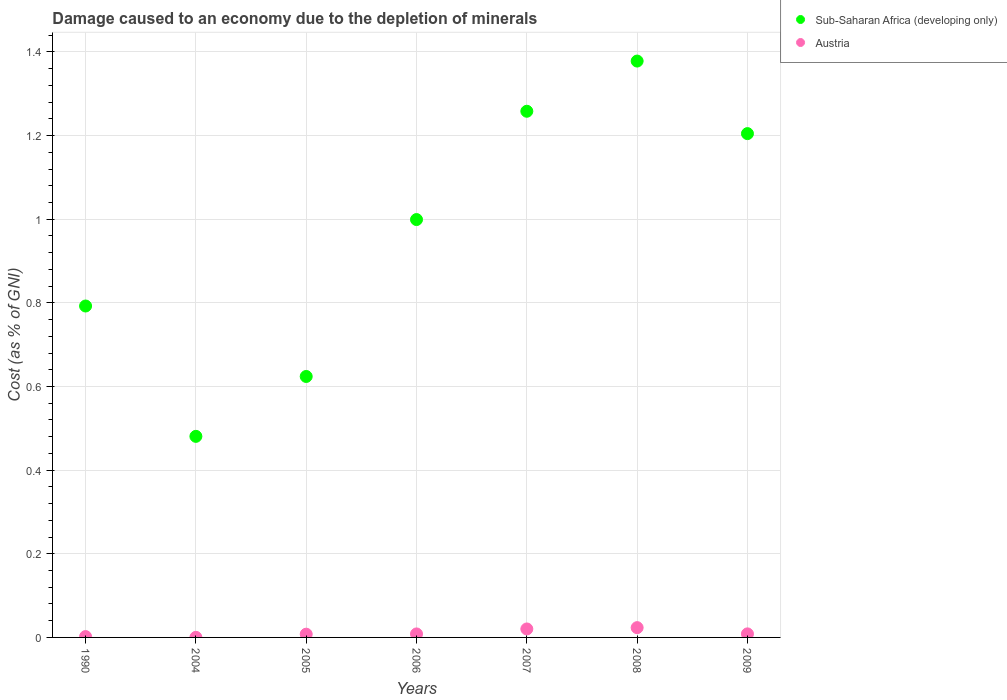How many different coloured dotlines are there?
Provide a short and direct response. 2. Is the number of dotlines equal to the number of legend labels?
Ensure brevity in your answer.  Yes. What is the cost of damage caused due to the depletion of minerals in Sub-Saharan Africa (developing only) in 2009?
Provide a succinct answer. 1.2. Across all years, what is the maximum cost of damage caused due to the depletion of minerals in Sub-Saharan Africa (developing only)?
Provide a succinct answer. 1.38. Across all years, what is the minimum cost of damage caused due to the depletion of minerals in Sub-Saharan Africa (developing only)?
Your answer should be very brief. 0.48. In which year was the cost of damage caused due to the depletion of minerals in Sub-Saharan Africa (developing only) maximum?
Provide a succinct answer. 2008. In which year was the cost of damage caused due to the depletion of minerals in Sub-Saharan Africa (developing only) minimum?
Ensure brevity in your answer.  2004. What is the total cost of damage caused due to the depletion of minerals in Sub-Saharan Africa (developing only) in the graph?
Provide a short and direct response. 6.74. What is the difference between the cost of damage caused due to the depletion of minerals in Austria in 2004 and that in 2005?
Keep it short and to the point. -0.01. What is the difference between the cost of damage caused due to the depletion of minerals in Sub-Saharan Africa (developing only) in 2005 and the cost of damage caused due to the depletion of minerals in Austria in 1990?
Keep it short and to the point. 0.62. What is the average cost of damage caused due to the depletion of minerals in Sub-Saharan Africa (developing only) per year?
Provide a succinct answer. 0.96. In the year 2006, what is the difference between the cost of damage caused due to the depletion of minerals in Austria and cost of damage caused due to the depletion of minerals in Sub-Saharan Africa (developing only)?
Provide a short and direct response. -0.99. What is the ratio of the cost of damage caused due to the depletion of minerals in Austria in 1990 to that in 2004?
Make the answer very short. 10.62. Is the cost of damage caused due to the depletion of minerals in Sub-Saharan Africa (developing only) in 2004 less than that in 2009?
Make the answer very short. Yes. What is the difference between the highest and the second highest cost of damage caused due to the depletion of minerals in Austria?
Ensure brevity in your answer.  0. What is the difference between the highest and the lowest cost of damage caused due to the depletion of minerals in Austria?
Offer a terse response. 0.02. Is the sum of the cost of damage caused due to the depletion of minerals in Sub-Saharan Africa (developing only) in 2004 and 2008 greater than the maximum cost of damage caused due to the depletion of minerals in Austria across all years?
Your answer should be compact. Yes. Does the cost of damage caused due to the depletion of minerals in Austria monotonically increase over the years?
Keep it short and to the point. No. Is the cost of damage caused due to the depletion of minerals in Sub-Saharan Africa (developing only) strictly greater than the cost of damage caused due to the depletion of minerals in Austria over the years?
Your response must be concise. Yes. Is the cost of damage caused due to the depletion of minerals in Sub-Saharan Africa (developing only) strictly less than the cost of damage caused due to the depletion of minerals in Austria over the years?
Make the answer very short. No. How many years are there in the graph?
Make the answer very short. 7. What is the difference between two consecutive major ticks on the Y-axis?
Provide a short and direct response. 0.2. Are the values on the major ticks of Y-axis written in scientific E-notation?
Give a very brief answer. No. Does the graph contain grids?
Keep it short and to the point. Yes. How many legend labels are there?
Offer a terse response. 2. How are the legend labels stacked?
Offer a very short reply. Vertical. What is the title of the graph?
Make the answer very short. Damage caused to an economy due to the depletion of minerals. Does "Myanmar" appear as one of the legend labels in the graph?
Ensure brevity in your answer.  No. What is the label or title of the Y-axis?
Keep it short and to the point. Cost (as % of GNI). What is the Cost (as % of GNI) in Sub-Saharan Africa (developing only) in 1990?
Keep it short and to the point. 0.79. What is the Cost (as % of GNI) in Austria in 1990?
Offer a very short reply. 0. What is the Cost (as % of GNI) in Sub-Saharan Africa (developing only) in 2004?
Your response must be concise. 0.48. What is the Cost (as % of GNI) of Austria in 2004?
Provide a succinct answer. 0. What is the Cost (as % of GNI) in Sub-Saharan Africa (developing only) in 2005?
Ensure brevity in your answer.  0.62. What is the Cost (as % of GNI) of Austria in 2005?
Keep it short and to the point. 0.01. What is the Cost (as % of GNI) of Sub-Saharan Africa (developing only) in 2006?
Give a very brief answer. 1. What is the Cost (as % of GNI) of Austria in 2006?
Offer a terse response. 0.01. What is the Cost (as % of GNI) of Sub-Saharan Africa (developing only) in 2007?
Offer a terse response. 1.26. What is the Cost (as % of GNI) in Austria in 2007?
Make the answer very short. 0.02. What is the Cost (as % of GNI) of Sub-Saharan Africa (developing only) in 2008?
Offer a very short reply. 1.38. What is the Cost (as % of GNI) in Austria in 2008?
Make the answer very short. 0.02. What is the Cost (as % of GNI) in Sub-Saharan Africa (developing only) in 2009?
Keep it short and to the point. 1.2. What is the Cost (as % of GNI) in Austria in 2009?
Offer a very short reply. 0.01. Across all years, what is the maximum Cost (as % of GNI) of Sub-Saharan Africa (developing only)?
Provide a short and direct response. 1.38. Across all years, what is the maximum Cost (as % of GNI) in Austria?
Make the answer very short. 0.02. Across all years, what is the minimum Cost (as % of GNI) of Sub-Saharan Africa (developing only)?
Make the answer very short. 0.48. Across all years, what is the minimum Cost (as % of GNI) of Austria?
Make the answer very short. 0. What is the total Cost (as % of GNI) in Sub-Saharan Africa (developing only) in the graph?
Keep it short and to the point. 6.74. What is the total Cost (as % of GNI) in Austria in the graph?
Offer a terse response. 0.07. What is the difference between the Cost (as % of GNI) of Sub-Saharan Africa (developing only) in 1990 and that in 2004?
Give a very brief answer. 0.31. What is the difference between the Cost (as % of GNI) of Austria in 1990 and that in 2004?
Your answer should be compact. 0. What is the difference between the Cost (as % of GNI) of Sub-Saharan Africa (developing only) in 1990 and that in 2005?
Your response must be concise. 0.17. What is the difference between the Cost (as % of GNI) of Austria in 1990 and that in 2005?
Offer a terse response. -0.01. What is the difference between the Cost (as % of GNI) of Sub-Saharan Africa (developing only) in 1990 and that in 2006?
Make the answer very short. -0.21. What is the difference between the Cost (as % of GNI) in Austria in 1990 and that in 2006?
Ensure brevity in your answer.  -0.01. What is the difference between the Cost (as % of GNI) of Sub-Saharan Africa (developing only) in 1990 and that in 2007?
Your answer should be compact. -0.47. What is the difference between the Cost (as % of GNI) in Austria in 1990 and that in 2007?
Offer a terse response. -0.02. What is the difference between the Cost (as % of GNI) of Sub-Saharan Africa (developing only) in 1990 and that in 2008?
Keep it short and to the point. -0.59. What is the difference between the Cost (as % of GNI) in Austria in 1990 and that in 2008?
Keep it short and to the point. -0.02. What is the difference between the Cost (as % of GNI) of Sub-Saharan Africa (developing only) in 1990 and that in 2009?
Ensure brevity in your answer.  -0.41. What is the difference between the Cost (as % of GNI) of Austria in 1990 and that in 2009?
Make the answer very short. -0.01. What is the difference between the Cost (as % of GNI) of Sub-Saharan Africa (developing only) in 2004 and that in 2005?
Make the answer very short. -0.14. What is the difference between the Cost (as % of GNI) in Austria in 2004 and that in 2005?
Offer a terse response. -0.01. What is the difference between the Cost (as % of GNI) in Sub-Saharan Africa (developing only) in 2004 and that in 2006?
Offer a terse response. -0.52. What is the difference between the Cost (as % of GNI) of Austria in 2004 and that in 2006?
Offer a terse response. -0.01. What is the difference between the Cost (as % of GNI) in Sub-Saharan Africa (developing only) in 2004 and that in 2007?
Offer a terse response. -0.78. What is the difference between the Cost (as % of GNI) in Austria in 2004 and that in 2007?
Ensure brevity in your answer.  -0.02. What is the difference between the Cost (as % of GNI) in Sub-Saharan Africa (developing only) in 2004 and that in 2008?
Your answer should be compact. -0.9. What is the difference between the Cost (as % of GNI) of Austria in 2004 and that in 2008?
Give a very brief answer. -0.02. What is the difference between the Cost (as % of GNI) in Sub-Saharan Africa (developing only) in 2004 and that in 2009?
Provide a short and direct response. -0.72. What is the difference between the Cost (as % of GNI) in Austria in 2004 and that in 2009?
Make the answer very short. -0.01. What is the difference between the Cost (as % of GNI) of Sub-Saharan Africa (developing only) in 2005 and that in 2006?
Provide a short and direct response. -0.38. What is the difference between the Cost (as % of GNI) in Austria in 2005 and that in 2006?
Give a very brief answer. -0. What is the difference between the Cost (as % of GNI) in Sub-Saharan Africa (developing only) in 2005 and that in 2007?
Your response must be concise. -0.63. What is the difference between the Cost (as % of GNI) of Austria in 2005 and that in 2007?
Offer a very short reply. -0.01. What is the difference between the Cost (as % of GNI) in Sub-Saharan Africa (developing only) in 2005 and that in 2008?
Give a very brief answer. -0.75. What is the difference between the Cost (as % of GNI) in Austria in 2005 and that in 2008?
Offer a terse response. -0.02. What is the difference between the Cost (as % of GNI) in Sub-Saharan Africa (developing only) in 2005 and that in 2009?
Ensure brevity in your answer.  -0.58. What is the difference between the Cost (as % of GNI) of Austria in 2005 and that in 2009?
Make the answer very short. -0. What is the difference between the Cost (as % of GNI) of Sub-Saharan Africa (developing only) in 2006 and that in 2007?
Provide a succinct answer. -0.26. What is the difference between the Cost (as % of GNI) in Austria in 2006 and that in 2007?
Offer a terse response. -0.01. What is the difference between the Cost (as % of GNI) of Sub-Saharan Africa (developing only) in 2006 and that in 2008?
Give a very brief answer. -0.38. What is the difference between the Cost (as % of GNI) in Austria in 2006 and that in 2008?
Your answer should be compact. -0.01. What is the difference between the Cost (as % of GNI) in Sub-Saharan Africa (developing only) in 2006 and that in 2009?
Ensure brevity in your answer.  -0.21. What is the difference between the Cost (as % of GNI) of Austria in 2006 and that in 2009?
Make the answer very short. -0. What is the difference between the Cost (as % of GNI) in Sub-Saharan Africa (developing only) in 2007 and that in 2008?
Your response must be concise. -0.12. What is the difference between the Cost (as % of GNI) in Austria in 2007 and that in 2008?
Ensure brevity in your answer.  -0. What is the difference between the Cost (as % of GNI) of Sub-Saharan Africa (developing only) in 2007 and that in 2009?
Provide a short and direct response. 0.05. What is the difference between the Cost (as % of GNI) in Austria in 2007 and that in 2009?
Make the answer very short. 0.01. What is the difference between the Cost (as % of GNI) in Sub-Saharan Africa (developing only) in 2008 and that in 2009?
Your answer should be compact. 0.17. What is the difference between the Cost (as % of GNI) in Austria in 2008 and that in 2009?
Your response must be concise. 0.01. What is the difference between the Cost (as % of GNI) in Sub-Saharan Africa (developing only) in 1990 and the Cost (as % of GNI) in Austria in 2004?
Offer a terse response. 0.79. What is the difference between the Cost (as % of GNI) in Sub-Saharan Africa (developing only) in 1990 and the Cost (as % of GNI) in Austria in 2005?
Keep it short and to the point. 0.78. What is the difference between the Cost (as % of GNI) of Sub-Saharan Africa (developing only) in 1990 and the Cost (as % of GNI) of Austria in 2006?
Offer a terse response. 0.78. What is the difference between the Cost (as % of GNI) in Sub-Saharan Africa (developing only) in 1990 and the Cost (as % of GNI) in Austria in 2007?
Provide a short and direct response. 0.77. What is the difference between the Cost (as % of GNI) in Sub-Saharan Africa (developing only) in 1990 and the Cost (as % of GNI) in Austria in 2008?
Provide a short and direct response. 0.77. What is the difference between the Cost (as % of GNI) in Sub-Saharan Africa (developing only) in 1990 and the Cost (as % of GNI) in Austria in 2009?
Offer a very short reply. 0.78. What is the difference between the Cost (as % of GNI) of Sub-Saharan Africa (developing only) in 2004 and the Cost (as % of GNI) of Austria in 2005?
Provide a succinct answer. 0.47. What is the difference between the Cost (as % of GNI) in Sub-Saharan Africa (developing only) in 2004 and the Cost (as % of GNI) in Austria in 2006?
Offer a terse response. 0.47. What is the difference between the Cost (as % of GNI) in Sub-Saharan Africa (developing only) in 2004 and the Cost (as % of GNI) in Austria in 2007?
Your response must be concise. 0.46. What is the difference between the Cost (as % of GNI) of Sub-Saharan Africa (developing only) in 2004 and the Cost (as % of GNI) of Austria in 2008?
Make the answer very short. 0.46. What is the difference between the Cost (as % of GNI) of Sub-Saharan Africa (developing only) in 2004 and the Cost (as % of GNI) of Austria in 2009?
Your answer should be very brief. 0.47. What is the difference between the Cost (as % of GNI) of Sub-Saharan Africa (developing only) in 2005 and the Cost (as % of GNI) of Austria in 2006?
Offer a very short reply. 0.62. What is the difference between the Cost (as % of GNI) in Sub-Saharan Africa (developing only) in 2005 and the Cost (as % of GNI) in Austria in 2007?
Offer a very short reply. 0.6. What is the difference between the Cost (as % of GNI) in Sub-Saharan Africa (developing only) in 2005 and the Cost (as % of GNI) in Austria in 2008?
Offer a very short reply. 0.6. What is the difference between the Cost (as % of GNI) in Sub-Saharan Africa (developing only) in 2005 and the Cost (as % of GNI) in Austria in 2009?
Offer a terse response. 0.62. What is the difference between the Cost (as % of GNI) of Sub-Saharan Africa (developing only) in 2006 and the Cost (as % of GNI) of Austria in 2008?
Your response must be concise. 0.98. What is the difference between the Cost (as % of GNI) in Sub-Saharan Africa (developing only) in 2007 and the Cost (as % of GNI) in Austria in 2008?
Your answer should be very brief. 1.23. What is the difference between the Cost (as % of GNI) of Sub-Saharan Africa (developing only) in 2007 and the Cost (as % of GNI) of Austria in 2009?
Offer a terse response. 1.25. What is the difference between the Cost (as % of GNI) of Sub-Saharan Africa (developing only) in 2008 and the Cost (as % of GNI) of Austria in 2009?
Your answer should be compact. 1.37. What is the average Cost (as % of GNI) of Sub-Saharan Africa (developing only) per year?
Keep it short and to the point. 0.96. What is the average Cost (as % of GNI) of Austria per year?
Your answer should be compact. 0.01. In the year 1990, what is the difference between the Cost (as % of GNI) in Sub-Saharan Africa (developing only) and Cost (as % of GNI) in Austria?
Ensure brevity in your answer.  0.79. In the year 2004, what is the difference between the Cost (as % of GNI) of Sub-Saharan Africa (developing only) and Cost (as % of GNI) of Austria?
Your answer should be very brief. 0.48. In the year 2005, what is the difference between the Cost (as % of GNI) in Sub-Saharan Africa (developing only) and Cost (as % of GNI) in Austria?
Provide a succinct answer. 0.62. In the year 2006, what is the difference between the Cost (as % of GNI) of Sub-Saharan Africa (developing only) and Cost (as % of GNI) of Austria?
Provide a short and direct response. 0.99. In the year 2007, what is the difference between the Cost (as % of GNI) of Sub-Saharan Africa (developing only) and Cost (as % of GNI) of Austria?
Your answer should be very brief. 1.24. In the year 2008, what is the difference between the Cost (as % of GNI) of Sub-Saharan Africa (developing only) and Cost (as % of GNI) of Austria?
Your answer should be compact. 1.35. In the year 2009, what is the difference between the Cost (as % of GNI) of Sub-Saharan Africa (developing only) and Cost (as % of GNI) of Austria?
Keep it short and to the point. 1.2. What is the ratio of the Cost (as % of GNI) of Sub-Saharan Africa (developing only) in 1990 to that in 2004?
Provide a succinct answer. 1.65. What is the ratio of the Cost (as % of GNI) of Austria in 1990 to that in 2004?
Your answer should be very brief. 10.62. What is the ratio of the Cost (as % of GNI) of Sub-Saharan Africa (developing only) in 1990 to that in 2005?
Give a very brief answer. 1.27. What is the ratio of the Cost (as % of GNI) of Austria in 1990 to that in 2005?
Make the answer very short. 0.26. What is the ratio of the Cost (as % of GNI) of Sub-Saharan Africa (developing only) in 1990 to that in 2006?
Your response must be concise. 0.79. What is the ratio of the Cost (as % of GNI) in Austria in 1990 to that in 2006?
Provide a succinct answer. 0.24. What is the ratio of the Cost (as % of GNI) of Sub-Saharan Africa (developing only) in 1990 to that in 2007?
Your response must be concise. 0.63. What is the ratio of the Cost (as % of GNI) in Austria in 1990 to that in 2007?
Your answer should be compact. 0.1. What is the ratio of the Cost (as % of GNI) of Sub-Saharan Africa (developing only) in 1990 to that in 2008?
Offer a very short reply. 0.57. What is the ratio of the Cost (as % of GNI) of Austria in 1990 to that in 2008?
Make the answer very short. 0.09. What is the ratio of the Cost (as % of GNI) in Sub-Saharan Africa (developing only) in 1990 to that in 2009?
Ensure brevity in your answer.  0.66. What is the ratio of the Cost (as % of GNI) of Austria in 1990 to that in 2009?
Your response must be concise. 0.24. What is the ratio of the Cost (as % of GNI) of Sub-Saharan Africa (developing only) in 2004 to that in 2005?
Make the answer very short. 0.77. What is the ratio of the Cost (as % of GNI) in Austria in 2004 to that in 2005?
Keep it short and to the point. 0.02. What is the ratio of the Cost (as % of GNI) in Sub-Saharan Africa (developing only) in 2004 to that in 2006?
Give a very brief answer. 0.48. What is the ratio of the Cost (as % of GNI) in Austria in 2004 to that in 2006?
Give a very brief answer. 0.02. What is the ratio of the Cost (as % of GNI) in Sub-Saharan Africa (developing only) in 2004 to that in 2007?
Keep it short and to the point. 0.38. What is the ratio of the Cost (as % of GNI) of Austria in 2004 to that in 2007?
Provide a short and direct response. 0.01. What is the ratio of the Cost (as % of GNI) of Sub-Saharan Africa (developing only) in 2004 to that in 2008?
Ensure brevity in your answer.  0.35. What is the ratio of the Cost (as % of GNI) in Austria in 2004 to that in 2008?
Offer a very short reply. 0.01. What is the ratio of the Cost (as % of GNI) in Sub-Saharan Africa (developing only) in 2004 to that in 2009?
Offer a very short reply. 0.4. What is the ratio of the Cost (as % of GNI) of Austria in 2004 to that in 2009?
Your response must be concise. 0.02. What is the ratio of the Cost (as % of GNI) in Sub-Saharan Africa (developing only) in 2005 to that in 2006?
Your response must be concise. 0.62. What is the ratio of the Cost (as % of GNI) in Austria in 2005 to that in 2006?
Ensure brevity in your answer.  0.93. What is the ratio of the Cost (as % of GNI) of Sub-Saharan Africa (developing only) in 2005 to that in 2007?
Keep it short and to the point. 0.5. What is the ratio of the Cost (as % of GNI) in Austria in 2005 to that in 2007?
Give a very brief answer. 0.38. What is the ratio of the Cost (as % of GNI) in Sub-Saharan Africa (developing only) in 2005 to that in 2008?
Give a very brief answer. 0.45. What is the ratio of the Cost (as % of GNI) in Austria in 2005 to that in 2008?
Ensure brevity in your answer.  0.33. What is the ratio of the Cost (as % of GNI) of Sub-Saharan Africa (developing only) in 2005 to that in 2009?
Provide a short and direct response. 0.52. What is the ratio of the Cost (as % of GNI) of Austria in 2005 to that in 2009?
Provide a short and direct response. 0.91. What is the ratio of the Cost (as % of GNI) in Sub-Saharan Africa (developing only) in 2006 to that in 2007?
Offer a terse response. 0.79. What is the ratio of the Cost (as % of GNI) of Austria in 2006 to that in 2007?
Your response must be concise. 0.41. What is the ratio of the Cost (as % of GNI) of Sub-Saharan Africa (developing only) in 2006 to that in 2008?
Your answer should be very brief. 0.72. What is the ratio of the Cost (as % of GNI) of Austria in 2006 to that in 2008?
Your response must be concise. 0.36. What is the ratio of the Cost (as % of GNI) of Sub-Saharan Africa (developing only) in 2006 to that in 2009?
Your answer should be compact. 0.83. What is the ratio of the Cost (as % of GNI) of Austria in 2006 to that in 2009?
Make the answer very short. 0.98. What is the ratio of the Cost (as % of GNI) in Sub-Saharan Africa (developing only) in 2007 to that in 2008?
Offer a very short reply. 0.91. What is the ratio of the Cost (as % of GNI) in Austria in 2007 to that in 2008?
Provide a short and direct response. 0.87. What is the ratio of the Cost (as % of GNI) in Sub-Saharan Africa (developing only) in 2007 to that in 2009?
Ensure brevity in your answer.  1.04. What is the ratio of the Cost (as % of GNI) of Austria in 2007 to that in 2009?
Give a very brief answer. 2.38. What is the ratio of the Cost (as % of GNI) in Sub-Saharan Africa (developing only) in 2008 to that in 2009?
Offer a terse response. 1.14. What is the ratio of the Cost (as % of GNI) in Austria in 2008 to that in 2009?
Provide a short and direct response. 2.75. What is the difference between the highest and the second highest Cost (as % of GNI) in Sub-Saharan Africa (developing only)?
Provide a succinct answer. 0.12. What is the difference between the highest and the second highest Cost (as % of GNI) of Austria?
Offer a terse response. 0. What is the difference between the highest and the lowest Cost (as % of GNI) of Sub-Saharan Africa (developing only)?
Provide a succinct answer. 0.9. What is the difference between the highest and the lowest Cost (as % of GNI) of Austria?
Offer a terse response. 0.02. 